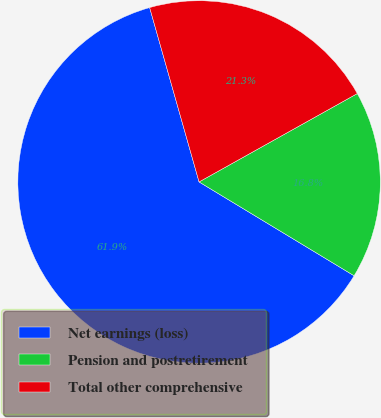<chart> <loc_0><loc_0><loc_500><loc_500><pie_chart><fcel>Net earnings (loss)<fcel>Pension and postretirement<fcel>Total other comprehensive<nl><fcel>61.94%<fcel>16.77%<fcel>21.29%<nl></chart> 